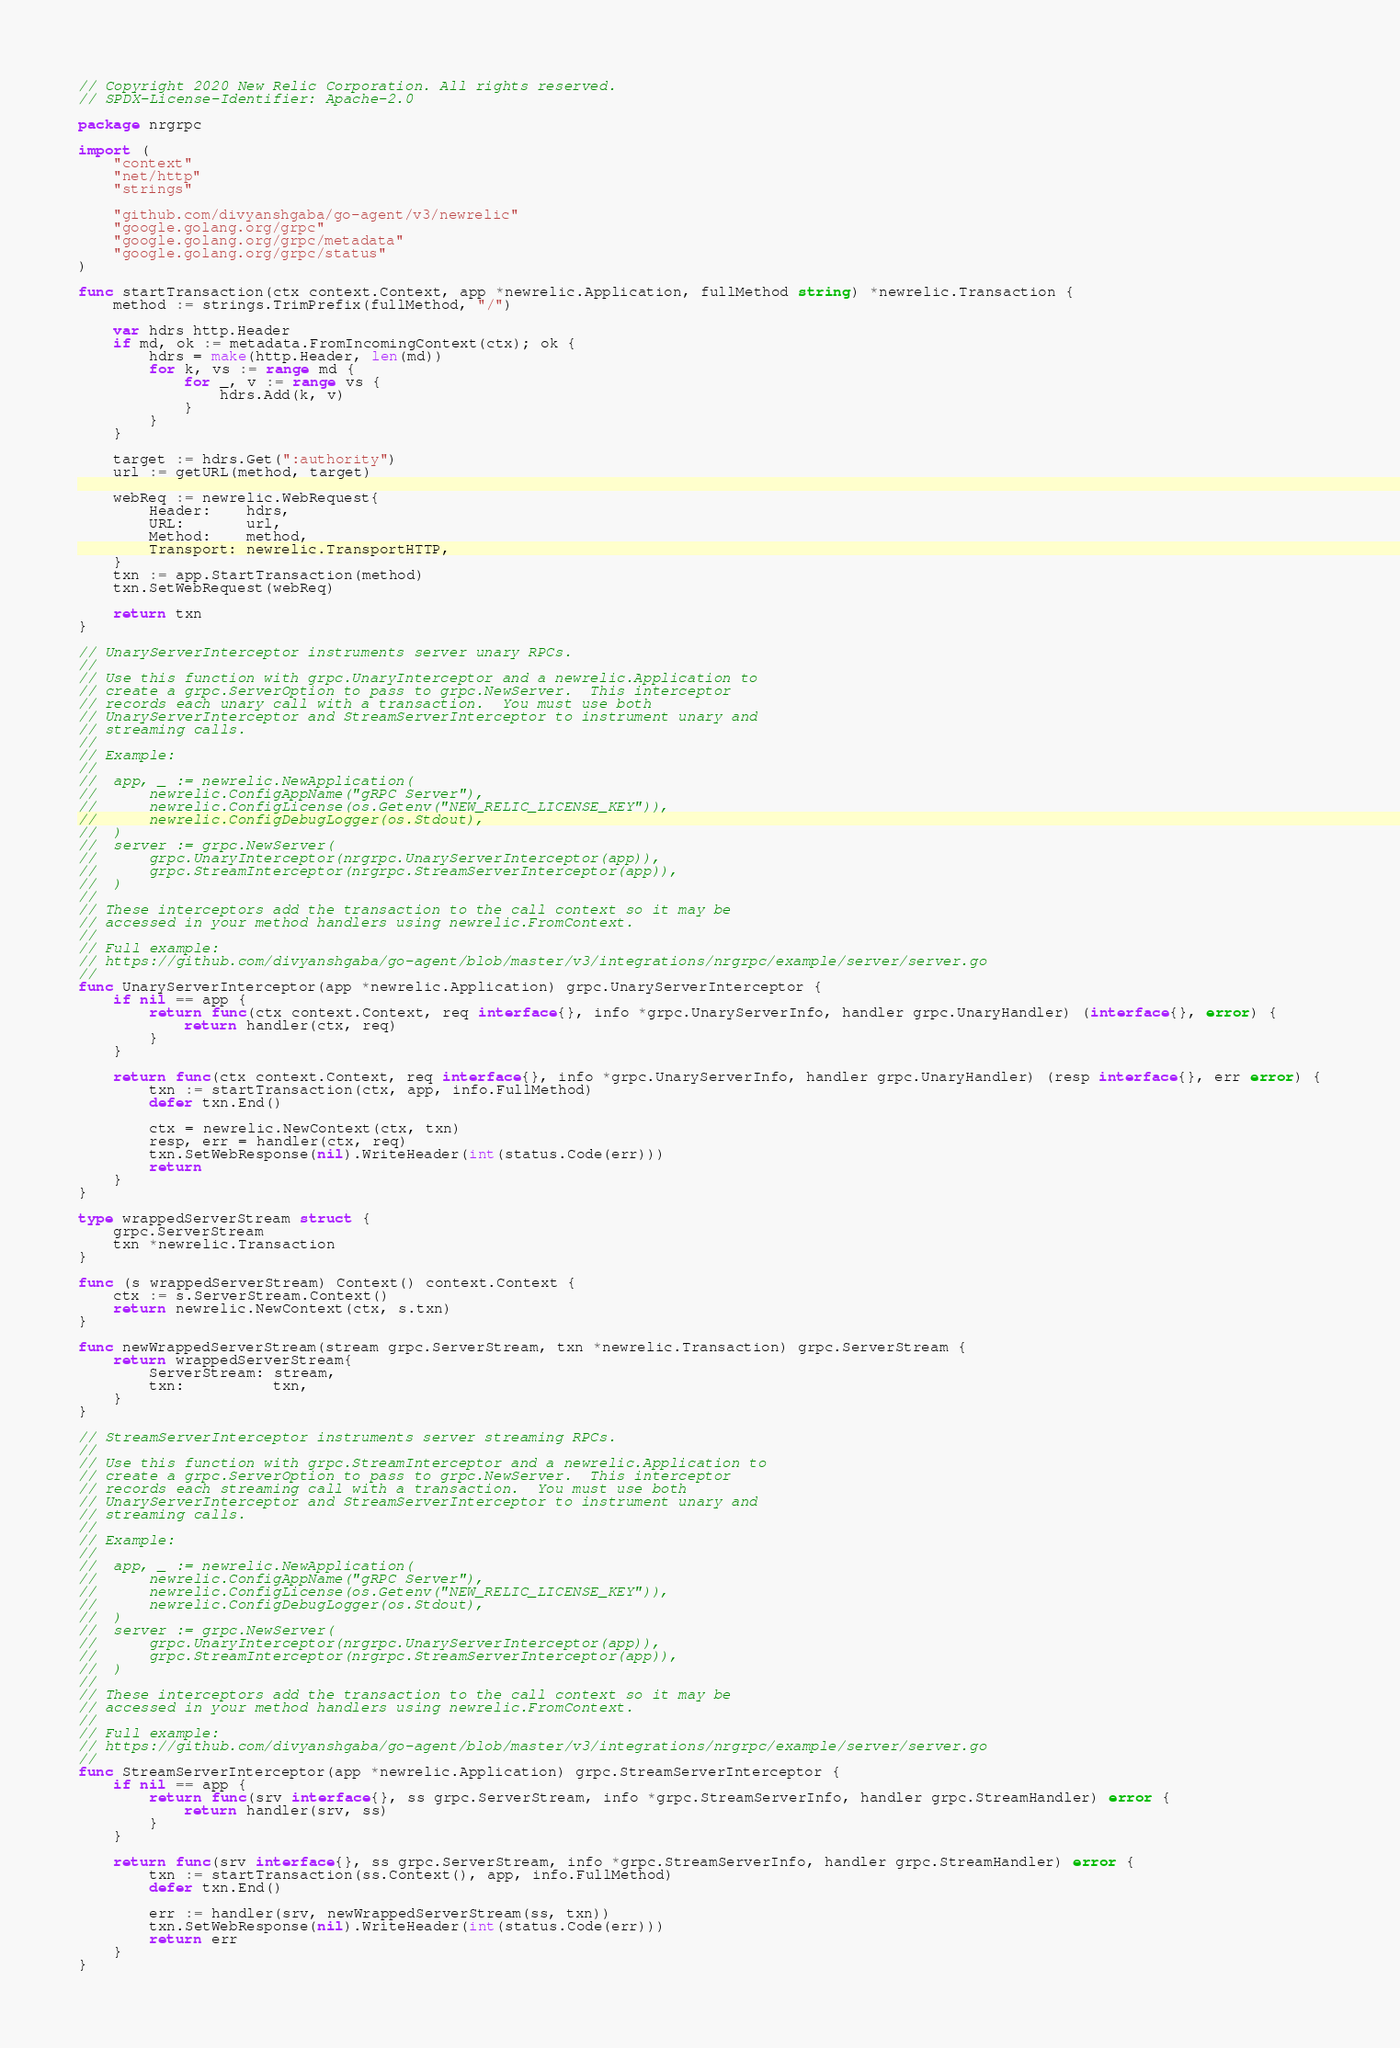<code> <loc_0><loc_0><loc_500><loc_500><_Go_>// Copyright 2020 New Relic Corporation. All rights reserved.
// SPDX-License-Identifier: Apache-2.0

package nrgrpc

import (
	"context"
	"net/http"
	"strings"

	"github.com/divyanshgaba/go-agent/v3/newrelic"
	"google.golang.org/grpc"
	"google.golang.org/grpc/metadata"
	"google.golang.org/grpc/status"
)

func startTransaction(ctx context.Context, app *newrelic.Application, fullMethod string) *newrelic.Transaction {
	method := strings.TrimPrefix(fullMethod, "/")

	var hdrs http.Header
	if md, ok := metadata.FromIncomingContext(ctx); ok {
		hdrs = make(http.Header, len(md))
		for k, vs := range md {
			for _, v := range vs {
				hdrs.Add(k, v)
			}
		}
	}

	target := hdrs.Get(":authority")
	url := getURL(method, target)

	webReq := newrelic.WebRequest{
		Header:    hdrs,
		URL:       url,
		Method:    method,
		Transport: newrelic.TransportHTTP,
	}
	txn := app.StartTransaction(method)
	txn.SetWebRequest(webReq)

	return txn
}

// UnaryServerInterceptor instruments server unary RPCs.
//
// Use this function with grpc.UnaryInterceptor and a newrelic.Application to
// create a grpc.ServerOption to pass to grpc.NewServer.  This interceptor
// records each unary call with a transaction.  You must use both
// UnaryServerInterceptor and StreamServerInterceptor to instrument unary and
// streaming calls.
//
// Example:
//
//	app, _ := newrelic.NewApplication(
//		newrelic.ConfigAppName("gRPC Server"),
//		newrelic.ConfigLicense(os.Getenv("NEW_RELIC_LICENSE_KEY")),
//		newrelic.ConfigDebugLogger(os.Stdout),
//	)
//	server := grpc.NewServer(
//		grpc.UnaryInterceptor(nrgrpc.UnaryServerInterceptor(app)),
//		grpc.StreamInterceptor(nrgrpc.StreamServerInterceptor(app)),
//	)
//
// These interceptors add the transaction to the call context so it may be
// accessed in your method handlers using newrelic.FromContext.
//
// Full example:
// https://github.com/divyanshgaba/go-agent/blob/master/v3/integrations/nrgrpc/example/server/server.go
//
func UnaryServerInterceptor(app *newrelic.Application) grpc.UnaryServerInterceptor {
	if nil == app {
		return func(ctx context.Context, req interface{}, info *grpc.UnaryServerInfo, handler grpc.UnaryHandler) (interface{}, error) {
			return handler(ctx, req)
		}
	}

	return func(ctx context.Context, req interface{}, info *grpc.UnaryServerInfo, handler grpc.UnaryHandler) (resp interface{}, err error) {
		txn := startTransaction(ctx, app, info.FullMethod)
		defer txn.End()

		ctx = newrelic.NewContext(ctx, txn)
		resp, err = handler(ctx, req)
		txn.SetWebResponse(nil).WriteHeader(int(status.Code(err)))
		return
	}
}

type wrappedServerStream struct {
	grpc.ServerStream
	txn *newrelic.Transaction
}

func (s wrappedServerStream) Context() context.Context {
	ctx := s.ServerStream.Context()
	return newrelic.NewContext(ctx, s.txn)
}

func newWrappedServerStream(stream grpc.ServerStream, txn *newrelic.Transaction) grpc.ServerStream {
	return wrappedServerStream{
		ServerStream: stream,
		txn:          txn,
	}
}

// StreamServerInterceptor instruments server streaming RPCs.
//
// Use this function with grpc.StreamInterceptor and a newrelic.Application to
// create a grpc.ServerOption to pass to grpc.NewServer.  This interceptor
// records each streaming call with a transaction.  You must use both
// UnaryServerInterceptor and StreamServerInterceptor to instrument unary and
// streaming calls.
//
// Example:
//
//	app, _ := newrelic.NewApplication(
//		newrelic.ConfigAppName("gRPC Server"),
//		newrelic.ConfigLicense(os.Getenv("NEW_RELIC_LICENSE_KEY")),
//		newrelic.ConfigDebugLogger(os.Stdout),
//	)
//	server := grpc.NewServer(
//		grpc.UnaryInterceptor(nrgrpc.UnaryServerInterceptor(app)),
//		grpc.StreamInterceptor(nrgrpc.StreamServerInterceptor(app)),
//	)
//
// These interceptors add the transaction to the call context so it may be
// accessed in your method handlers using newrelic.FromContext.
//
// Full example:
// https://github.com/divyanshgaba/go-agent/blob/master/v3/integrations/nrgrpc/example/server/server.go
//
func StreamServerInterceptor(app *newrelic.Application) grpc.StreamServerInterceptor {
	if nil == app {
		return func(srv interface{}, ss grpc.ServerStream, info *grpc.StreamServerInfo, handler grpc.StreamHandler) error {
			return handler(srv, ss)
		}
	}

	return func(srv interface{}, ss grpc.ServerStream, info *grpc.StreamServerInfo, handler grpc.StreamHandler) error {
		txn := startTransaction(ss.Context(), app, info.FullMethod)
		defer txn.End()

		err := handler(srv, newWrappedServerStream(ss, txn))
		txn.SetWebResponse(nil).WriteHeader(int(status.Code(err)))
		return err
	}
}
</code> 